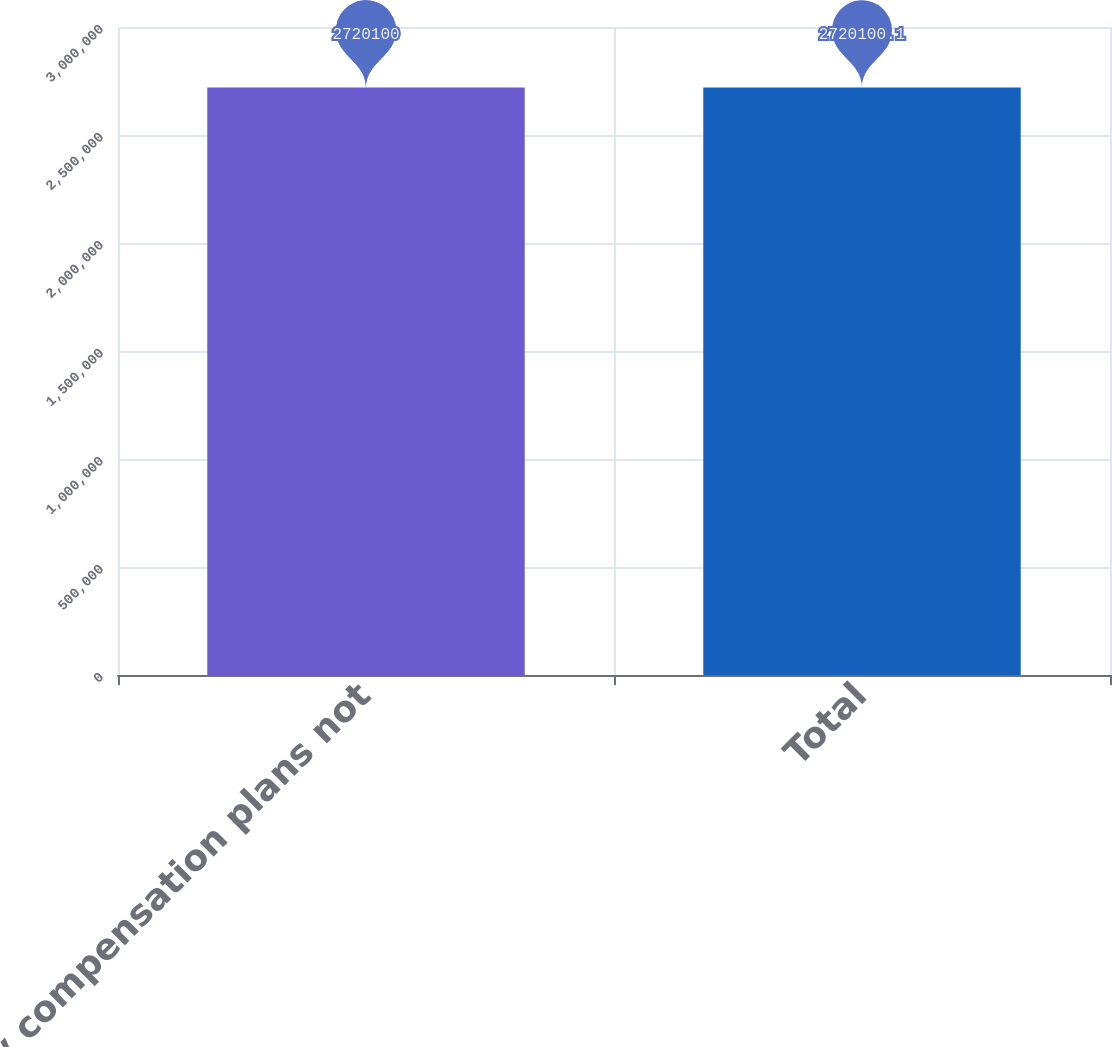Convert chart to OTSL. <chart><loc_0><loc_0><loc_500><loc_500><bar_chart><fcel>Equity compensation plans not<fcel>Total<nl><fcel>2.7201e+06<fcel>2.7201e+06<nl></chart> 